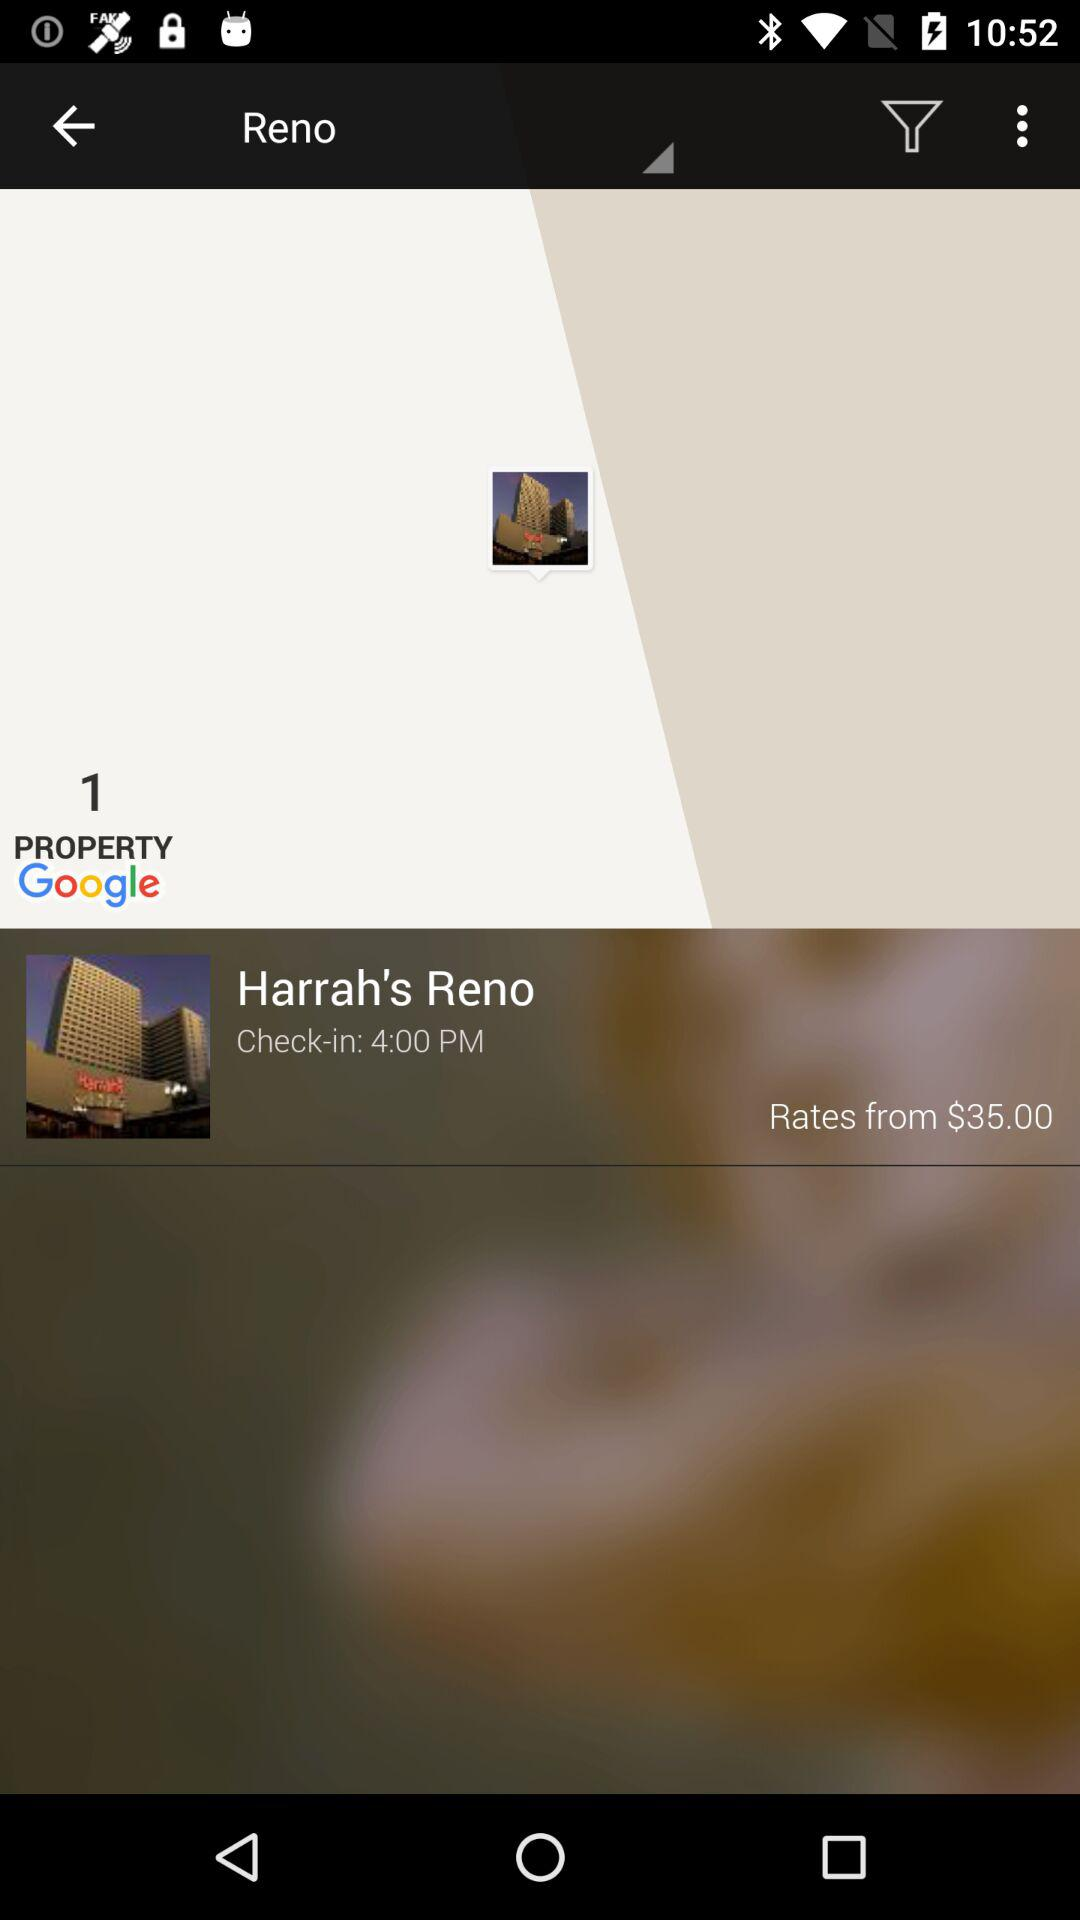What is the check-in time? The check-in time is 4:00 PM. 